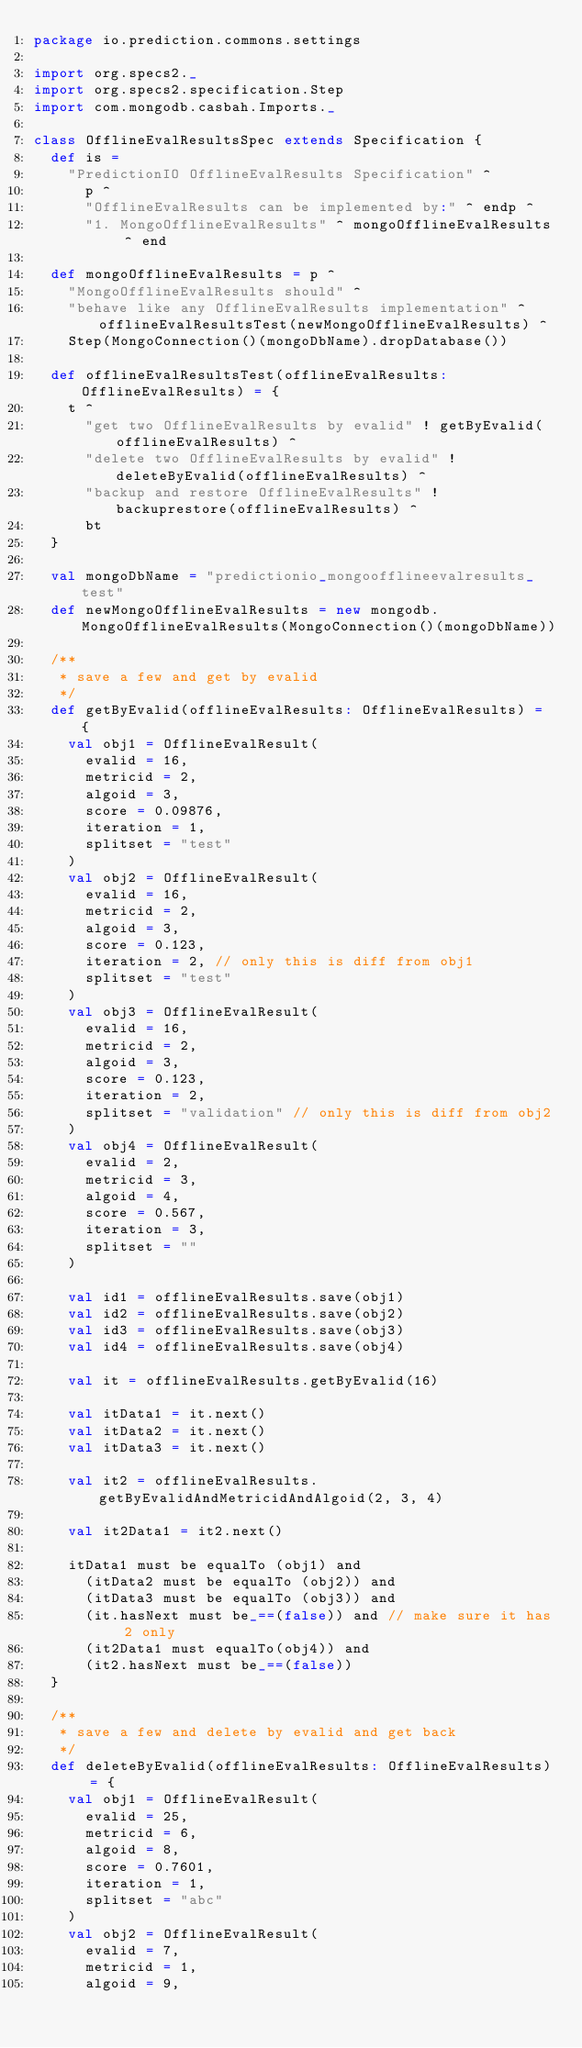Convert code to text. <code><loc_0><loc_0><loc_500><loc_500><_Scala_>package io.prediction.commons.settings

import org.specs2._
import org.specs2.specification.Step
import com.mongodb.casbah.Imports._

class OfflineEvalResultsSpec extends Specification {
  def is =
    "PredictionIO OfflineEvalResults Specification" ^
      p ^
      "OfflineEvalResults can be implemented by:" ^ endp ^
      "1. MongoOfflineEvalResults" ^ mongoOfflineEvalResults ^ end

  def mongoOfflineEvalResults = p ^
    "MongoOfflineEvalResults should" ^
    "behave like any OfflineEvalResults implementation" ^ offlineEvalResultsTest(newMongoOfflineEvalResults) ^
    Step(MongoConnection()(mongoDbName).dropDatabase())

  def offlineEvalResultsTest(offlineEvalResults: OfflineEvalResults) = {
    t ^
      "get two OfflineEvalResults by evalid" ! getByEvalid(offlineEvalResults) ^
      "delete two OfflineEvalResults by evalid" ! deleteByEvalid(offlineEvalResults) ^
      "backup and restore OfflineEvalResults" ! backuprestore(offlineEvalResults) ^
      bt
  }

  val mongoDbName = "predictionio_mongoofflineevalresults_test"
  def newMongoOfflineEvalResults = new mongodb.MongoOfflineEvalResults(MongoConnection()(mongoDbName))

  /**
   * save a few and get by evalid
   */
  def getByEvalid(offlineEvalResults: OfflineEvalResults) = {
    val obj1 = OfflineEvalResult(
      evalid = 16,
      metricid = 2,
      algoid = 3,
      score = 0.09876,
      iteration = 1,
      splitset = "test"
    )
    val obj2 = OfflineEvalResult(
      evalid = 16,
      metricid = 2,
      algoid = 3,
      score = 0.123,
      iteration = 2, // only this is diff from obj1
      splitset = "test"
    )
    val obj3 = OfflineEvalResult(
      evalid = 16,
      metricid = 2,
      algoid = 3,
      score = 0.123,
      iteration = 2,
      splitset = "validation" // only this is diff from obj2
    )
    val obj4 = OfflineEvalResult(
      evalid = 2,
      metricid = 3,
      algoid = 4,
      score = 0.567,
      iteration = 3,
      splitset = ""
    )

    val id1 = offlineEvalResults.save(obj1)
    val id2 = offlineEvalResults.save(obj2)
    val id3 = offlineEvalResults.save(obj3)
    val id4 = offlineEvalResults.save(obj4)

    val it = offlineEvalResults.getByEvalid(16)

    val itData1 = it.next()
    val itData2 = it.next()
    val itData3 = it.next()

    val it2 = offlineEvalResults.getByEvalidAndMetricidAndAlgoid(2, 3, 4)

    val it2Data1 = it2.next()

    itData1 must be equalTo (obj1) and
      (itData2 must be equalTo (obj2)) and
      (itData3 must be equalTo (obj3)) and
      (it.hasNext must be_==(false)) and // make sure it has 2 only
      (it2Data1 must equalTo(obj4)) and
      (it2.hasNext must be_==(false))
  }

  /**
   * save a few and delete by evalid and get back
   */
  def deleteByEvalid(offlineEvalResults: OfflineEvalResults) = {
    val obj1 = OfflineEvalResult(
      evalid = 25,
      metricid = 6,
      algoid = 8,
      score = 0.7601,
      iteration = 1,
      splitset = "abc"
    )
    val obj2 = OfflineEvalResult(
      evalid = 7,
      metricid = 1,
      algoid = 9,</code> 